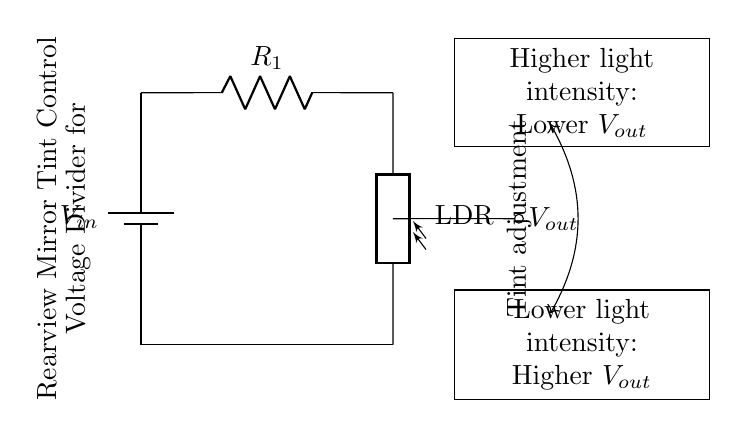What is the input voltage labeled in the circuit? The input voltage is labeled as V_in, which indicates the source voltage powering the circuit.
Answer: V_in What type of component is R_1? R_1 is a resistor, which is used in the circuit to limit the current and divide the voltage.
Answer: Resistor What does LDR stand for in this circuit? LDR stands for Light Dependent Resistor, a component whose resistance changes based on light intensity.
Answer: Light Dependent Resistor What happens to V_out as light intensity increases? As light intensity increases, the output voltage V_out decreases due to the nature of the voltage divider rule with an LDR.
Answer: Lower V_out What is the primary purpose of this voltage divider circuit? The primary purpose is to automatically adjust the tint of the rearview mirror based on light intensity.
Answer: Tint adjustment What does the lower light intensity result in for V_out? Lower light intensity results in a higher V_out, which means the mirror will become darker to reduce glare.
Answer: Higher V_out 